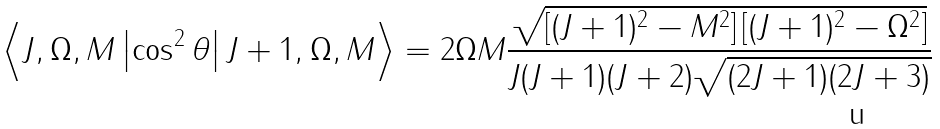<formula> <loc_0><loc_0><loc_500><loc_500>\Big < J , \Omega , M \left | \cos ^ { 2 } \theta \right | J + 1 , \Omega , M \Big > = 2 \Omega M \frac { \sqrt { \left [ ( J + 1 ) ^ { 2 } - M ^ { 2 } \right ] \left [ ( J + 1 ) ^ { 2 } - \Omega ^ { 2 } \right ] } } { J ( J + 1 ) ( J + 2 ) \sqrt { ( 2 J + 1 ) ( 2 J + 3 ) } }</formula> 